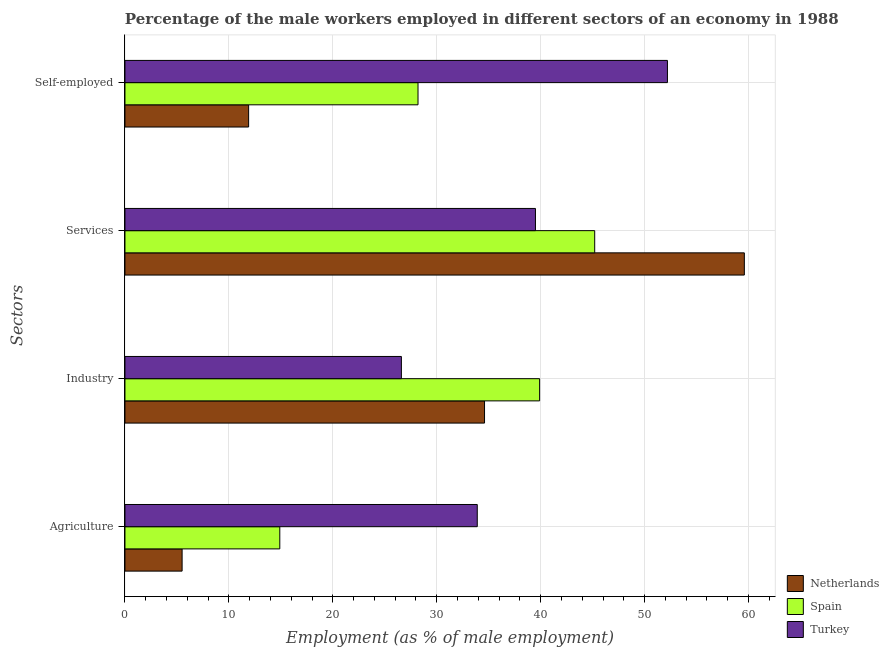Are the number of bars per tick equal to the number of legend labels?
Offer a terse response. Yes. How many bars are there on the 2nd tick from the bottom?
Your response must be concise. 3. What is the label of the 4th group of bars from the top?
Provide a short and direct response. Agriculture. Across all countries, what is the maximum percentage of male workers in agriculture?
Your response must be concise. 33.9. Across all countries, what is the minimum percentage of self employed male workers?
Ensure brevity in your answer.  11.9. In which country was the percentage of male workers in agriculture minimum?
Your answer should be very brief. Netherlands. What is the total percentage of self employed male workers in the graph?
Your response must be concise. 92.3. What is the difference between the percentage of male workers in agriculture in Turkey and that in Netherlands?
Make the answer very short. 28.4. What is the difference between the percentage of male workers in services in Netherlands and the percentage of male workers in industry in Spain?
Your response must be concise. 19.7. What is the average percentage of male workers in industry per country?
Your answer should be compact. 33.7. What is the difference between the percentage of male workers in industry and percentage of self employed male workers in Netherlands?
Ensure brevity in your answer.  22.7. What is the ratio of the percentage of self employed male workers in Turkey to that in Netherlands?
Provide a succinct answer. 4.39. Is the difference between the percentage of self employed male workers in Turkey and Netherlands greater than the difference between the percentage of male workers in services in Turkey and Netherlands?
Ensure brevity in your answer.  Yes. What is the difference between the highest and the second highest percentage of male workers in services?
Your response must be concise. 14.4. What is the difference between the highest and the lowest percentage of male workers in services?
Provide a succinct answer. 20.1. In how many countries, is the percentage of self employed male workers greater than the average percentage of self employed male workers taken over all countries?
Offer a terse response. 1. Is it the case that in every country, the sum of the percentage of male workers in agriculture and percentage of male workers in services is greater than the sum of percentage of male workers in industry and percentage of self employed male workers?
Your answer should be very brief. No. How many bars are there?
Give a very brief answer. 12. Are all the bars in the graph horizontal?
Make the answer very short. Yes. How many countries are there in the graph?
Your answer should be compact. 3. Does the graph contain any zero values?
Offer a terse response. No. Does the graph contain grids?
Provide a short and direct response. Yes. What is the title of the graph?
Your answer should be very brief. Percentage of the male workers employed in different sectors of an economy in 1988. Does "High income" appear as one of the legend labels in the graph?
Your response must be concise. No. What is the label or title of the X-axis?
Your answer should be compact. Employment (as % of male employment). What is the label or title of the Y-axis?
Ensure brevity in your answer.  Sectors. What is the Employment (as % of male employment) of Netherlands in Agriculture?
Give a very brief answer. 5.5. What is the Employment (as % of male employment) of Spain in Agriculture?
Give a very brief answer. 14.9. What is the Employment (as % of male employment) in Turkey in Agriculture?
Make the answer very short. 33.9. What is the Employment (as % of male employment) in Netherlands in Industry?
Give a very brief answer. 34.6. What is the Employment (as % of male employment) of Spain in Industry?
Your answer should be compact. 39.9. What is the Employment (as % of male employment) of Turkey in Industry?
Your response must be concise. 26.6. What is the Employment (as % of male employment) of Netherlands in Services?
Provide a short and direct response. 59.6. What is the Employment (as % of male employment) of Spain in Services?
Ensure brevity in your answer.  45.2. What is the Employment (as % of male employment) of Turkey in Services?
Keep it short and to the point. 39.5. What is the Employment (as % of male employment) of Netherlands in Self-employed?
Your response must be concise. 11.9. What is the Employment (as % of male employment) of Spain in Self-employed?
Make the answer very short. 28.2. What is the Employment (as % of male employment) in Turkey in Self-employed?
Give a very brief answer. 52.2. Across all Sectors, what is the maximum Employment (as % of male employment) of Netherlands?
Your answer should be compact. 59.6. Across all Sectors, what is the maximum Employment (as % of male employment) of Spain?
Keep it short and to the point. 45.2. Across all Sectors, what is the maximum Employment (as % of male employment) in Turkey?
Keep it short and to the point. 52.2. Across all Sectors, what is the minimum Employment (as % of male employment) of Netherlands?
Provide a succinct answer. 5.5. Across all Sectors, what is the minimum Employment (as % of male employment) in Spain?
Provide a succinct answer. 14.9. Across all Sectors, what is the minimum Employment (as % of male employment) of Turkey?
Give a very brief answer. 26.6. What is the total Employment (as % of male employment) in Netherlands in the graph?
Give a very brief answer. 111.6. What is the total Employment (as % of male employment) in Spain in the graph?
Offer a terse response. 128.2. What is the total Employment (as % of male employment) in Turkey in the graph?
Provide a succinct answer. 152.2. What is the difference between the Employment (as % of male employment) in Netherlands in Agriculture and that in Industry?
Offer a terse response. -29.1. What is the difference between the Employment (as % of male employment) in Netherlands in Agriculture and that in Services?
Give a very brief answer. -54.1. What is the difference between the Employment (as % of male employment) of Spain in Agriculture and that in Services?
Offer a very short reply. -30.3. What is the difference between the Employment (as % of male employment) of Turkey in Agriculture and that in Services?
Your answer should be compact. -5.6. What is the difference between the Employment (as % of male employment) of Turkey in Agriculture and that in Self-employed?
Provide a succinct answer. -18.3. What is the difference between the Employment (as % of male employment) of Netherlands in Industry and that in Services?
Provide a short and direct response. -25. What is the difference between the Employment (as % of male employment) of Spain in Industry and that in Services?
Ensure brevity in your answer.  -5.3. What is the difference between the Employment (as % of male employment) of Netherlands in Industry and that in Self-employed?
Provide a short and direct response. 22.7. What is the difference between the Employment (as % of male employment) of Turkey in Industry and that in Self-employed?
Make the answer very short. -25.6. What is the difference between the Employment (as % of male employment) in Netherlands in Services and that in Self-employed?
Make the answer very short. 47.7. What is the difference between the Employment (as % of male employment) of Netherlands in Agriculture and the Employment (as % of male employment) of Spain in Industry?
Provide a succinct answer. -34.4. What is the difference between the Employment (as % of male employment) of Netherlands in Agriculture and the Employment (as % of male employment) of Turkey in Industry?
Give a very brief answer. -21.1. What is the difference between the Employment (as % of male employment) of Spain in Agriculture and the Employment (as % of male employment) of Turkey in Industry?
Ensure brevity in your answer.  -11.7. What is the difference between the Employment (as % of male employment) of Netherlands in Agriculture and the Employment (as % of male employment) of Spain in Services?
Make the answer very short. -39.7. What is the difference between the Employment (as % of male employment) of Netherlands in Agriculture and the Employment (as % of male employment) of Turkey in Services?
Offer a terse response. -34. What is the difference between the Employment (as % of male employment) in Spain in Agriculture and the Employment (as % of male employment) in Turkey in Services?
Offer a very short reply. -24.6. What is the difference between the Employment (as % of male employment) of Netherlands in Agriculture and the Employment (as % of male employment) of Spain in Self-employed?
Keep it short and to the point. -22.7. What is the difference between the Employment (as % of male employment) of Netherlands in Agriculture and the Employment (as % of male employment) of Turkey in Self-employed?
Keep it short and to the point. -46.7. What is the difference between the Employment (as % of male employment) in Spain in Agriculture and the Employment (as % of male employment) in Turkey in Self-employed?
Keep it short and to the point. -37.3. What is the difference between the Employment (as % of male employment) of Spain in Industry and the Employment (as % of male employment) of Turkey in Services?
Your answer should be very brief. 0.4. What is the difference between the Employment (as % of male employment) in Netherlands in Industry and the Employment (as % of male employment) in Turkey in Self-employed?
Give a very brief answer. -17.6. What is the difference between the Employment (as % of male employment) in Spain in Industry and the Employment (as % of male employment) in Turkey in Self-employed?
Your answer should be very brief. -12.3. What is the difference between the Employment (as % of male employment) in Netherlands in Services and the Employment (as % of male employment) in Spain in Self-employed?
Provide a short and direct response. 31.4. What is the difference between the Employment (as % of male employment) of Netherlands in Services and the Employment (as % of male employment) of Turkey in Self-employed?
Your answer should be compact. 7.4. What is the average Employment (as % of male employment) of Netherlands per Sectors?
Ensure brevity in your answer.  27.9. What is the average Employment (as % of male employment) of Spain per Sectors?
Provide a succinct answer. 32.05. What is the average Employment (as % of male employment) in Turkey per Sectors?
Provide a short and direct response. 38.05. What is the difference between the Employment (as % of male employment) of Netherlands and Employment (as % of male employment) of Turkey in Agriculture?
Give a very brief answer. -28.4. What is the difference between the Employment (as % of male employment) of Netherlands and Employment (as % of male employment) of Spain in Industry?
Your response must be concise. -5.3. What is the difference between the Employment (as % of male employment) of Netherlands and Employment (as % of male employment) of Spain in Services?
Make the answer very short. 14.4. What is the difference between the Employment (as % of male employment) of Netherlands and Employment (as % of male employment) of Turkey in Services?
Keep it short and to the point. 20.1. What is the difference between the Employment (as % of male employment) of Spain and Employment (as % of male employment) of Turkey in Services?
Give a very brief answer. 5.7. What is the difference between the Employment (as % of male employment) of Netherlands and Employment (as % of male employment) of Spain in Self-employed?
Offer a terse response. -16.3. What is the difference between the Employment (as % of male employment) in Netherlands and Employment (as % of male employment) in Turkey in Self-employed?
Offer a very short reply. -40.3. What is the difference between the Employment (as % of male employment) in Spain and Employment (as % of male employment) in Turkey in Self-employed?
Give a very brief answer. -24. What is the ratio of the Employment (as % of male employment) in Netherlands in Agriculture to that in Industry?
Ensure brevity in your answer.  0.16. What is the ratio of the Employment (as % of male employment) of Spain in Agriculture to that in Industry?
Offer a very short reply. 0.37. What is the ratio of the Employment (as % of male employment) of Turkey in Agriculture to that in Industry?
Your response must be concise. 1.27. What is the ratio of the Employment (as % of male employment) of Netherlands in Agriculture to that in Services?
Provide a succinct answer. 0.09. What is the ratio of the Employment (as % of male employment) of Spain in Agriculture to that in Services?
Offer a very short reply. 0.33. What is the ratio of the Employment (as % of male employment) of Turkey in Agriculture to that in Services?
Ensure brevity in your answer.  0.86. What is the ratio of the Employment (as % of male employment) of Netherlands in Agriculture to that in Self-employed?
Provide a succinct answer. 0.46. What is the ratio of the Employment (as % of male employment) in Spain in Agriculture to that in Self-employed?
Keep it short and to the point. 0.53. What is the ratio of the Employment (as % of male employment) in Turkey in Agriculture to that in Self-employed?
Keep it short and to the point. 0.65. What is the ratio of the Employment (as % of male employment) in Netherlands in Industry to that in Services?
Your answer should be very brief. 0.58. What is the ratio of the Employment (as % of male employment) of Spain in Industry to that in Services?
Your response must be concise. 0.88. What is the ratio of the Employment (as % of male employment) of Turkey in Industry to that in Services?
Keep it short and to the point. 0.67. What is the ratio of the Employment (as % of male employment) of Netherlands in Industry to that in Self-employed?
Make the answer very short. 2.91. What is the ratio of the Employment (as % of male employment) of Spain in Industry to that in Self-employed?
Give a very brief answer. 1.41. What is the ratio of the Employment (as % of male employment) of Turkey in Industry to that in Self-employed?
Your answer should be compact. 0.51. What is the ratio of the Employment (as % of male employment) in Netherlands in Services to that in Self-employed?
Give a very brief answer. 5.01. What is the ratio of the Employment (as % of male employment) of Spain in Services to that in Self-employed?
Your answer should be compact. 1.6. What is the ratio of the Employment (as % of male employment) in Turkey in Services to that in Self-employed?
Your answer should be very brief. 0.76. What is the difference between the highest and the second highest Employment (as % of male employment) in Netherlands?
Offer a terse response. 25. What is the difference between the highest and the second highest Employment (as % of male employment) in Spain?
Give a very brief answer. 5.3. What is the difference between the highest and the lowest Employment (as % of male employment) of Netherlands?
Offer a terse response. 54.1. What is the difference between the highest and the lowest Employment (as % of male employment) of Spain?
Offer a very short reply. 30.3. What is the difference between the highest and the lowest Employment (as % of male employment) in Turkey?
Give a very brief answer. 25.6. 